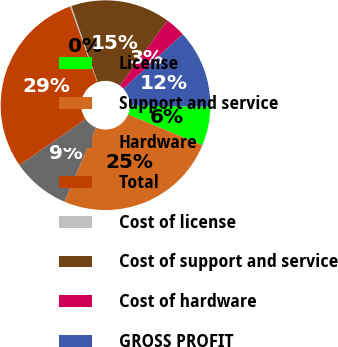<chart> <loc_0><loc_0><loc_500><loc_500><pie_chart><fcel>License<fcel>Support and service<fcel>Hardware<fcel>Total<fcel>Cost of license<fcel>Cost of support and service<fcel>Cost of hardware<fcel>GROSS PROFIT<nl><fcel>6.01%<fcel>25.17%<fcel>8.91%<fcel>29.23%<fcel>0.2%<fcel>15.32%<fcel>3.11%<fcel>12.06%<nl></chart> 